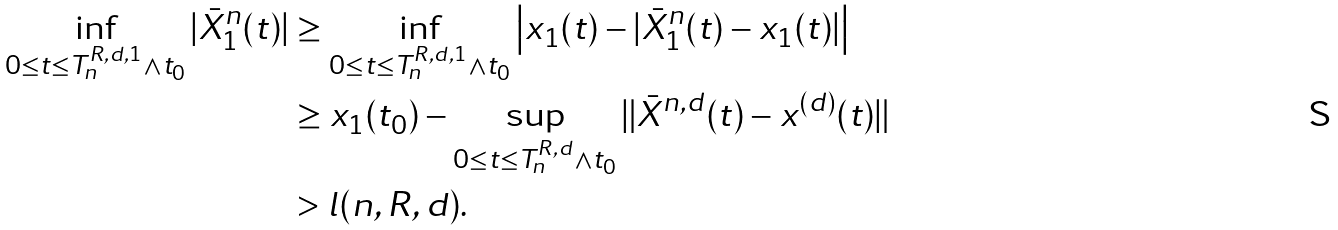<formula> <loc_0><loc_0><loc_500><loc_500>\inf _ { 0 \leq t \leq T _ { n } ^ { R , d , 1 } \wedge t _ { 0 } } | \bar { X } ^ { n } _ { 1 } ( t ) | & \geq \inf _ { 0 \leq t \leq T _ { n } ^ { R , d , 1 } \wedge t _ { 0 } } \left | x _ { 1 } ( t ) - | \bar { X } ^ { n } _ { 1 } ( t ) - x _ { 1 } ( t ) | \right | \\ & \geq x _ { 1 } ( t _ { 0 } ) - \sup _ { 0 \leq t \leq T _ { n } ^ { R , d } \wedge t _ { 0 } } \| \bar { X } ^ { n , d } ( t ) - x ^ { ( d ) } ( t ) \| \\ & > l ( n , R , d ) .</formula> 